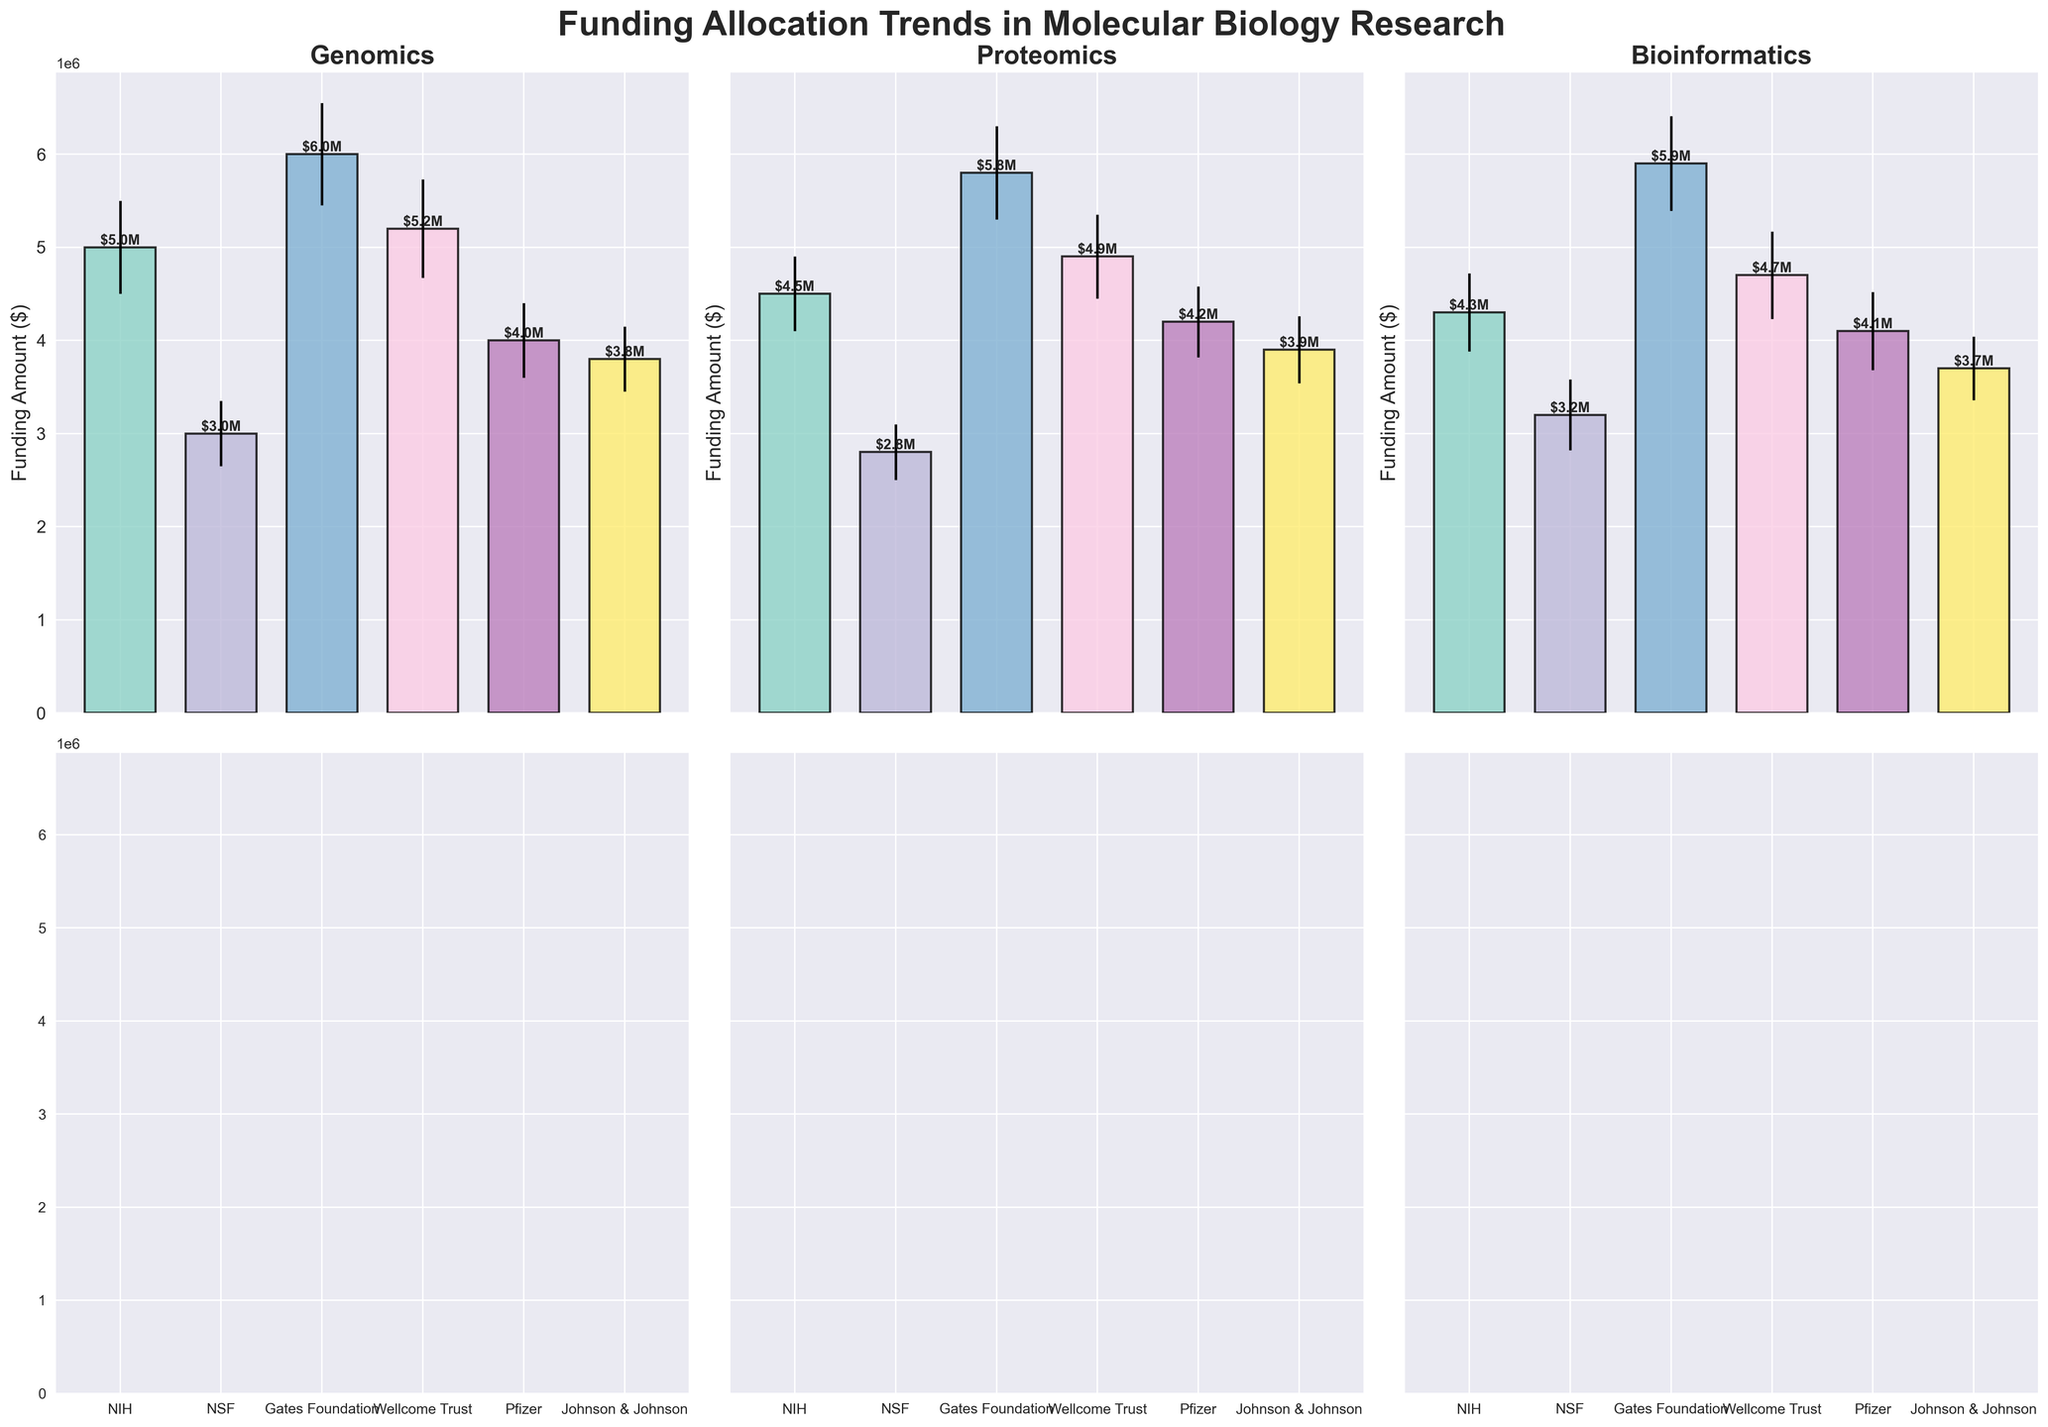Which funding body allocated the highest average funding for genomics? By observing the genomics subplot, the Gates Foundation is clearly allocating the highest average funding.
Answer: Gates Foundation What is the average funding allocated for proteomics by the NIH compared to the NSF? Check respective values for NIH (4.5M) and NSF (2.8M) under the proteomics subplot. Calculate the difference 4.5M - 2.8M = 1.7M
Answer: NIH allocates 1.7M more Which domain has the least funding variation by Wellcome Trust? Compare the error bars for each domain under Wellcome Trust. The smallest error bar is in proteomics.
Answer: Proteomics How does the funding for bioinformatics by Pfizer compare to Johnson & Johnson? In the bioinformatics subplot, Pfizer funding of 4.1M is higher than Johnson & Johnson's 3.7M.
Answer: Pfizer funds more What is the largest funding allocation with the smallest standard deviation? Look for the largest bar with the smallest error bar across all subplots. Gates Foundation's bioinformatics has high funding (6M) with moderate deviation (510K).
Answer: Gates Foundation, Bioinformatics What is the trend for genomics funding among all funding bodies? Compare genomic bars: Gates Foundation (6M), Wellcome Trust (5.2M), NIH (5M), Pfizer (4M), Johnson & Johnson (3.8M), NSF (3M).
Answer: Decreases from Gates Foundation to NSF Which private company provides the most funding for any domain? Check bars under private companies (Pfizer, Johnson & Johnson). Pfizer leads with 4.2M for proteomics.
Answer: Pfizer, Proteomics What is the total funding allocated by the Gates Foundation across all domains? Sum the Gates Foundation values in all subplots: 6M (Genomics) + 5.8M (Proteomics) + 5.9M (Bioinformatics) = 17.7M
Answer: $17.7M How does the range of funding by NIH compare across different domains? Measure the extent of each bar in NIH's subplots: Genomics (5M), Proteomics (4.5M), Bioinformatics (4.3M). Range is 5M - 4.3M = 0.7M.
Answer: 0.7M range 